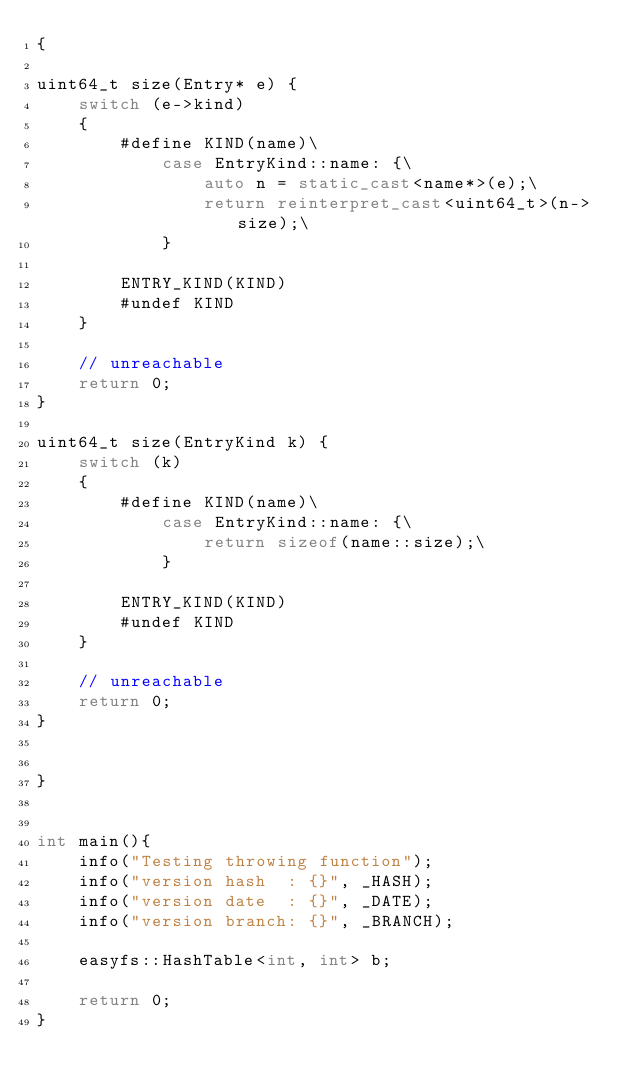<code> <loc_0><loc_0><loc_500><loc_500><_C++_>{

uint64_t size(Entry* e) {
    switch (e->kind)
    {
        #define KIND(name)\
            case EntryKind::name: {\
                auto n = static_cast<name*>(e);\
                return reinterpret_cast<uint64_t>(n->size);\
            }

        ENTRY_KIND(KIND)
        #undef KIND
    }

    // unreachable
    return 0;
}

uint64_t size(EntryKind k) {
    switch (k)
    {
        #define KIND(name)\
            case EntryKind::name: {\
                return sizeof(name::size);\
            }

        ENTRY_KIND(KIND)
        #undef KIND
    }

    // unreachable
    return 0;
}


}


int main(){
    info("Testing throwing function");
    info("version hash  : {}", _HASH);
    info("version date  : {}", _DATE);
    info("version branch: {}", _BRANCH);

    easyfs::HashTable<int, int> b;

    return 0;
}
</code> 